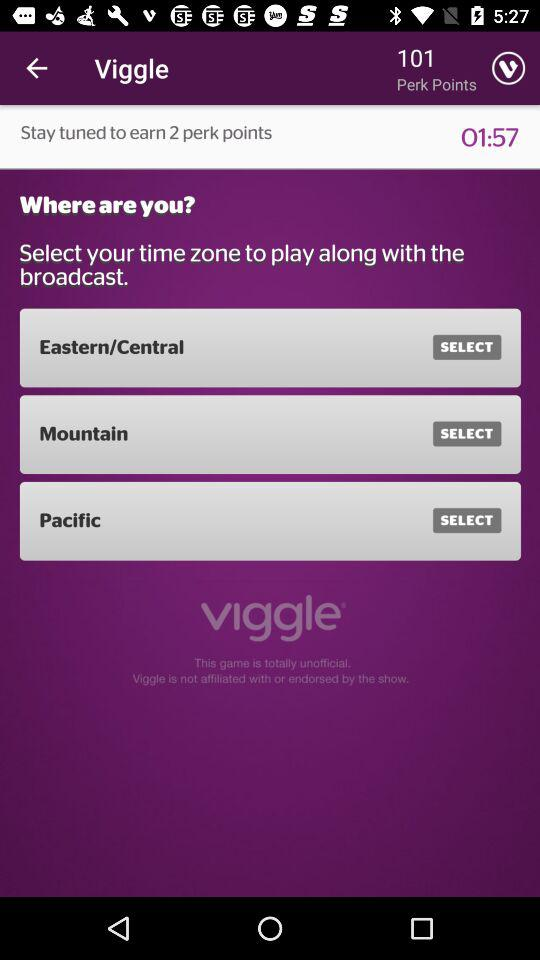How much time is left for earning 2 perk points? The time left for earning 2 perk points is 1 minute 57 seconds. 